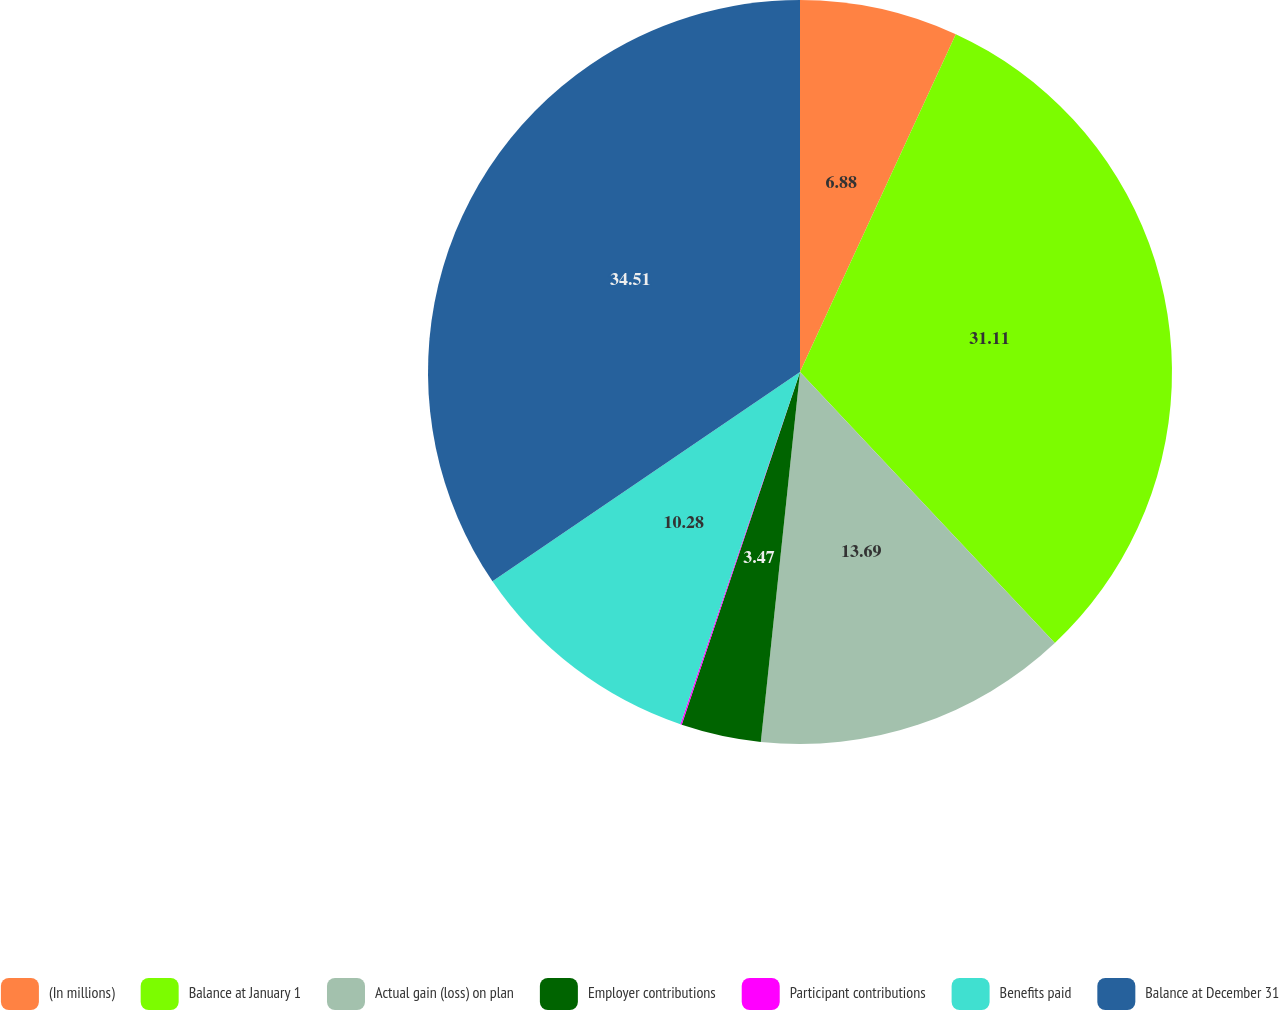Convert chart to OTSL. <chart><loc_0><loc_0><loc_500><loc_500><pie_chart><fcel>(In millions)<fcel>Balance at January 1<fcel>Actual gain (loss) on plan<fcel>Employer contributions<fcel>Participant contributions<fcel>Benefits paid<fcel>Balance at December 31<nl><fcel>6.88%<fcel>31.11%<fcel>13.69%<fcel>3.47%<fcel>0.06%<fcel>10.28%<fcel>34.51%<nl></chart> 